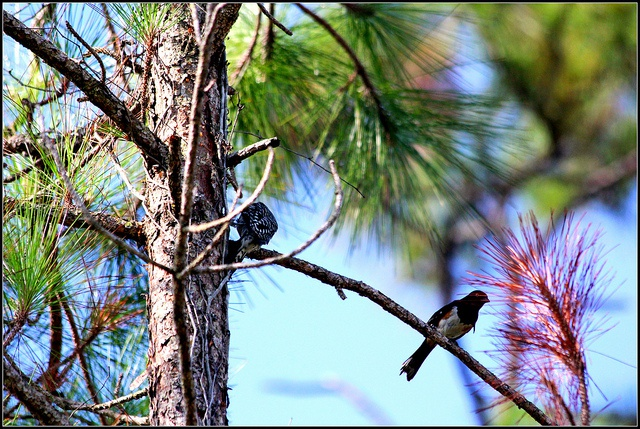Describe the objects in this image and their specific colors. I can see bird in black, gray, maroon, and lightblue tones and bird in black, navy, and gray tones in this image. 